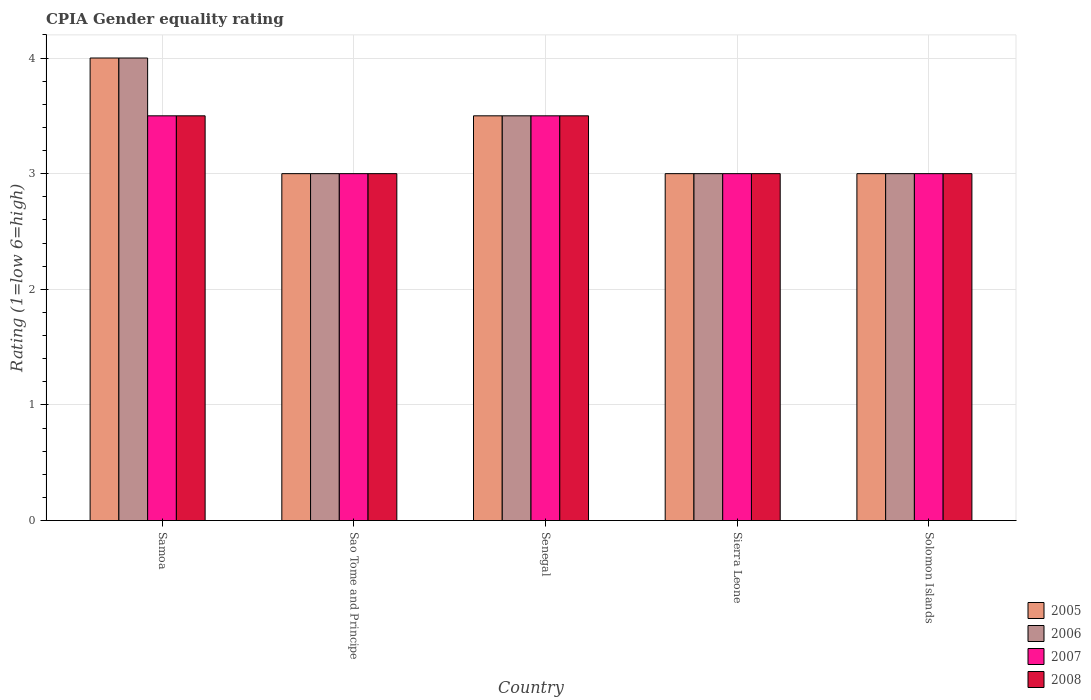How many different coloured bars are there?
Your answer should be very brief. 4. Are the number of bars on each tick of the X-axis equal?
Provide a short and direct response. Yes. What is the label of the 2nd group of bars from the left?
Your answer should be very brief. Sao Tome and Principe. In how many cases, is the number of bars for a given country not equal to the number of legend labels?
Provide a succinct answer. 0. What is the CPIA rating in 2007 in Senegal?
Keep it short and to the point. 3.5. In which country was the CPIA rating in 2007 maximum?
Ensure brevity in your answer.  Samoa. In which country was the CPIA rating in 2007 minimum?
Ensure brevity in your answer.  Sao Tome and Principe. What is the difference between the CPIA rating in 2006 in Senegal and that in Solomon Islands?
Ensure brevity in your answer.  0.5. What is the difference between the CPIA rating in 2005 in Sao Tome and Principe and the CPIA rating in 2006 in Sierra Leone?
Your answer should be compact. 0. In how many countries, is the CPIA rating in 2007 greater than 2.4?
Make the answer very short. 5. Is the difference between the CPIA rating in 2005 in Samoa and Sierra Leone greater than the difference between the CPIA rating in 2008 in Samoa and Sierra Leone?
Your answer should be very brief. Yes. What is the difference between the highest and the second highest CPIA rating in 2005?
Make the answer very short. -0.5. What is the difference between the highest and the lowest CPIA rating in 2006?
Keep it short and to the point. 1. In how many countries, is the CPIA rating in 2008 greater than the average CPIA rating in 2008 taken over all countries?
Provide a short and direct response. 2. Is the sum of the CPIA rating in 2007 in Sao Tome and Principe and Senegal greater than the maximum CPIA rating in 2006 across all countries?
Your answer should be compact. Yes. What does the 1st bar from the left in Samoa represents?
Make the answer very short. 2005. Is it the case that in every country, the sum of the CPIA rating in 2006 and CPIA rating in 2007 is greater than the CPIA rating in 2008?
Ensure brevity in your answer.  Yes. Are all the bars in the graph horizontal?
Your answer should be very brief. No. What is the difference between two consecutive major ticks on the Y-axis?
Your response must be concise. 1. Are the values on the major ticks of Y-axis written in scientific E-notation?
Your answer should be compact. No. Does the graph contain any zero values?
Give a very brief answer. No. Does the graph contain grids?
Provide a short and direct response. Yes. How many legend labels are there?
Give a very brief answer. 4. What is the title of the graph?
Provide a succinct answer. CPIA Gender equality rating. What is the Rating (1=low 6=high) of 2005 in Samoa?
Make the answer very short. 4. What is the Rating (1=low 6=high) of 2007 in Samoa?
Make the answer very short. 3.5. What is the Rating (1=low 6=high) of 2008 in Samoa?
Your response must be concise. 3.5. What is the Rating (1=low 6=high) in 2006 in Sao Tome and Principe?
Offer a terse response. 3. What is the Rating (1=low 6=high) in 2007 in Sao Tome and Principe?
Make the answer very short. 3. What is the Rating (1=low 6=high) of 2005 in Senegal?
Your response must be concise. 3.5. What is the Rating (1=low 6=high) of 2005 in Sierra Leone?
Your answer should be very brief. 3. What is the Rating (1=low 6=high) of 2006 in Sierra Leone?
Provide a short and direct response. 3. What is the Rating (1=low 6=high) in 2006 in Solomon Islands?
Provide a succinct answer. 3. What is the Rating (1=low 6=high) of 2007 in Solomon Islands?
Make the answer very short. 3. What is the Rating (1=low 6=high) of 2008 in Solomon Islands?
Keep it short and to the point. 3. Across all countries, what is the minimum Rating (1=low 6=high) in 2008?
Your answer should be compact. 3. What is the total Rating (1=low 6=high) of 2005 in the graph?
Keep it short and to the point. 16.5. What is the total Rating (1=low 6=high) of 2007 in the graph?
Keep it short and to the point. 16. What is the total Rating (1=low 6=high) in 2008 in the graph?
Provide a succinct answer. 16. What is the difference between the Rating (1=low 6=high) in 2005 in Samoa and that in Sao Tome and Principe?
Provide a succinct answer. 1. What is the difference between the Rating (1=low 6=high) in 2006 in Samoa and that in Sao Tome and Principe?
Your answer should be compact. 1. What is the difference between the Rating (1=low 6=high) in 2007 in Samoa and that in Sao Tome and Principe?
Give a very brief answer. 0.5. What is the difference between the Rating (1=low 6=high) of 2005 in Samoa and that in Senegal?
Your response must be concise. 0.5. What is the difference between the Rating (1=low 6=high) in 2006 in Samoa and that in Senegal?
Offer a terse response. 0.5. What is the difference between the Rating (1=low 6=high) of 2008 in Samoa and that in Senegal?
Make the answer very short. 0. What is the difference between the Rating (1=low 6=high) of 2006 in Samoa and that in Sierra Leone?
Offer a terse response. 1. What is the difference between the Rating (1=low 6=high) of 2005 in Samoa and that in Solomon Islands?
Give a very brief answer. 1. What is the difference between the Rating (1=low 6=high) in 2007 in Samoa and that in Solomon Islands?
Ensure brevity in your answer.  0.5. What is the difference between the Rating (1=low 6=high) of 2008 in Samoa and that in Solomon Islands?
Give a very brief answer. 0.5. What is the difference between the Rating (1=low 6=high) of 2005 in Sao Tome and Principe and that in Senegal?
Your response must be concise. -0.5. What is the difference between the Rating (1=low 6=high) in 2006 in Sao Tome and Principe and that in Senegal?
Ensure brevity in your answer.  -0.5. What is the difference between the Rating (1=low 6=high) of 2006 in Sao Tome and Principe and that in Sierra Leone?
Keep it short and to the point. 0. What is the difference between the Rating (1=low 6=high) of 2007 in Sao Tome and Principe and that in Sierra Leone?
Your response must be concise. 0. What is the difference between the Rating (1=low 6=high) in 2008 in Sao Tome and Principe and that in Sierra Leone?
Give a very brief answer. 0. What is the difference between the Rating (1=low 6=high) of 2008 in Sao Tome and Principe and that in Solomon Islands?
Give a very brief answer. 0. What is the difference between the Rating (1=low 6=high) in 2006 in Senegal and that in Sierra Leone?
Offer a terse response. 0.5. What is the difference between the Rating (1=low 6=high) in 2008 in Senegal and that in Sierra Leone?
Offer a very short reply. 0.5. What is the difference between the Rating (1=low 6=high) of 2005 in Senegal and that in Solomon Islands?
Ensure brevity in your answer.  0.5. What is the difference between the Rating (1=low 6=high) in 2008 in Senegal and that in Solomon Islands?
Offer a terse response. 0.5. What is the difference between the Rating (1=low 6=high) of 2008 in Sierra Leone and that in Solomon Islands?
Ensure brevity in your answer.  0. What is the difference between the Rating (1=low 6=high) in 2005 in Samoa and the Rating (1=low 6=high) in 2006 in Sao Tome and Principe?
Keep it short and to the point. 1. What is the difference between the Rating (1=low 6=high) of 2005 in Samoa and the Rating (1=low 6=high) of 2007 in Sao Tome and Principe?
Keep it short and to the point. 1. What is the difference between the Rating (1=low 6=high) in 2005 in Samoa and the Rating (1=low 6=high) in 2008 in Sao Tome and Principe?
Ensure brevity in your answer.  1. What is the difference between the Rating (1=low 6=high) of 2006 in Samoa and the Rating (1=low 6=high) of 2007 in Sao Tome and Principe?
Offer a terse response. 1. What is the difference between the Rating (1=low 6=high) of 2006 in Samoa and the Rating (1=low 6=high) of 2008 in Sao Tome and Principe?
Give a very brief answer. 1. What is the difference between the Rating (1=low 6=high) of 2007 in Samoa and the Rating (1=low 6=high) of 2008 in Sao Tome and Principe?
Provide a succinct answer. 0.5. What is the difference between the Rating (1=low 6=high) of 2005 in Samoa and the Rating (1=low 6=high) of 2006 in Senegal?
Provide a succinct answer. 0.5. What is the difference between the Rating (1=low 6=high) in 2006 in Samoa and the Rating (1=low 6=high) in 2008 in Senegal?
Make the answer very short. 0.5. What is the difference between the Rating (1=low 6=high) in 2005 in Samoa and the Rating (1=low 6=high) in 2006 in Solomon Islands?
Keep it short and to the point. 1. What is the difference between the Rating (1=low 6=high) in 2006 in Samoa and the Rating (1=low 6=high) in 2007 in Solomon Islands?
Ensure brevity in your answer.  1. What is the difference between the Rating (1=low 6=high) of 2007 in Samoa and the Rating (1=low 6=high) of 2008 in Solomon Islands?
Ensure brevity in your answer.  0.5. What is the difference between the Rating (1=low 6=high) of 2005 in Sao Tome and Principe and the Rating (1=low 6=high) of 2007 in Senegal?
Give a very brief answer. -0.5. What is the difference between the Rating (1=low 6=high) in 2006 in Sao Tome and Principe and the Rating (1=low 6=high) in 2008 in Senegal?
Offer a very short reply. -0.5. What is the difference between the Rating (1=low 6=high) of 2005 in Sao Tome and Principe and the Rating (1=low 6=high) of 2007 in Sierra Leone?
Make the answer very short. 0. What is the difference between the Rating (1=low 6=high) in 2006 in Sao Tome and Principe and the Rating (1=low 6=high) in 2007 in Sierra Leone?
Provide a short and direct response. 0. What is the difference between the Rating (1=low 6=high) of 2006 in Sao Tome and Principe and the Rating (1=low 6=high) of 2008 in Sierra Leone?
Offer a terse response. 0. What is the difference between the Rating (1=low 6=high) of 2005 in Sao Tome and Principe and the Rating (1=low 6=high) of 2006 in Solomon Islands?
Offer a very short reply. 0. What is the difference between the Rating (1=low 6=high) in 2005 in Sao Tome and Principe and the Rating (1=low 6=high) in 2007 in Solomon Islands?
Your response must be concise. 0. What is the difference between the Rating (1=low 6=high) in 2005 in Sao Tome and Principe and the Rating (1=low 6=high) in 2008 in Solomon Islands?
Ensure brevity in your answer.  0. What is the difference between the Rating (1=low 6=high) in 2007 in Sao Tome and Principe and the Rating (1=low 6=high) in 2008 in Solomon Islands?
Your answer should be very brief. 0. What is the difference between the Rating (1=low 6=high) in 2005 in Senegal and the Rating (1=low 6=high) in 2007 in Sierra Leone?
Offer a terse response. 0.5. What is the difference between the Rating (1=low 6=high) of 2005 in Senegal and the Rating (1=low 6=high) of 2008 in Sierra Leone?
Offer a terse response. 0.5. What is the difference between the Rating (1=low 6=high) in 2007 in Senegal and the Rating (1=low 6=high) in 2008 in Sierra Leone?
Offer a terse response. 0.5. What is the difference between the Rating (1=low 6=high) in 2005 in Senegal and the Rating (1=low 6=high) in 2006 in Solomon Islands?
Offer a very short reply. 0.5. What is the difference between the Rating (1=low 6=high) of 2005 in Senegal and the Rating (1=low 6=high) of 2008 in Solomon Islands?
Offer a very short reply. 0.5. What is the difference between the Rating (1=low 6=high) in 2006 in Senegal and the Rating (1=low 6=high) in 2007 in Solomon Islands?
Provide a short and direct response. 0.5. What is the difference between the Rating (1=low 6=high) of 2005 in Sierra Leone and the Rating (1=low 6=high) of 2006 in Solomon Islands?
Give a very brief answer. 0. What is the difference between the Rating (1=low 6=high) in 2005 in Sierra Leone and the Rating (1=low 6=high) in 2007 in Solomon Islands?
Offer a terse response. 0. What is the difference between the Rating (1=low 6=high) of 2005 in Sierra Leone and the Rating (1=low 6=high) of 2008 in Solomon Islands?
Your response must be concise. 0. What is the difference between the Rating (1=low 6=high) of 2007 in Sierra Leone and the Rating (1=low 6=high) of 2008 in Solomon Islands?
Provide a succinct answer. 0. What is the average Rating (1=low 6=high) in 2007 per country?
Make the answer very short. 3.2. What is the difference between the Rating (1=low 6=high) in 2005 and Rating (1=low 6=high) in 2006 in Samoa?
Give a very brief answer. 0. What is the difference between the Rating (1=low 6=high) in 2005 and Rating (1=low 6=high) in 2007 in Samoa?
Your response must be concise. 0.5. What is the difference between the Rating (1=low 6=high) of 2005 and Rating (1=low 6=high) of 2008 in Samoa?
Provide a short and direct response. 0.5. What is the difference between the Rating (1=low 6=high) in 2006 and Rating (1=low 6=high) in 2007 in Samoa?
Ensure brevity in your answer.  0.5. What is the difference between the Rating (1=low 6=high) in 2005 and Rating (1=low 6=high) in 2007 in Sao Tome and Principe?
Provide a succinct answer. 0. What is the difference between the Rating (1=low 6=high) in 2006 and Rating (1=low 6=high) in 2008 in Sao Tome and Principe?
Offer a terse response. 0. What is the difference between the Rating (1=low 6=high) in 2005 and Rating (1=low 6=high) in 2007 in Senegal?
Offer a very short reply. 0. What is the difference between the Rating (1=low 6=high) of 2006 and Rating (1=low 6=high) of 2007 in Senegal?
Give a very brief answer. 0. What is the difference between the Rating (1=low 6=high) in 2006 and Rating (1=low 6=high) in 2008 in Senegal?
Keep it short and to the point. 0. What is the difference between the Rating (1=low 6=high) in 2005 and Rating (1=low 6=high) in 2006 in Sierra Leone?
Your answer should be compact. 0. What is the difference between the Rating (1=low 6=high) in 2005 and Rating (1=low 6=high) in 2006 in Solomon Islands?
Provide a succinct answer. 0. What is the difference between the Rating (1=low 6=high) of 2005 and Rating (1=low 6=high) of 2008 in Solomon Islands?
Your answer should be compact. 0. What is the difference between the Rating (1=low 6=high) in 2006 and Rating (1=low 6=high) in 2007 in Solomon Islands?
Offer a terse response. 0. What is the difference between the Rating (1=low 6=high) in 2006 and Rating (1=low 6=high) in 2008 in Solomon Islands?
Provide a succinct answer. 0. What is the ratio of the Rating (1=low 6=high) of 2005 in Samoa to that in Sao Tome and Principe?
Ensure brevity in your answer.  1.33. What is the ratio of the Rating (1=low 6=high) of 2007 in Samoa to that in Sao Tome and Principe?
Your response must be concise. 1.17. What is the ratio of the Rating (1=low 6=high) in 2005 in Samoa to that in Senegal?
Provide a short and direct response. 1.14. What is the ratio of the Rating (1=low 6=high) of 2006 in Samoa to that in Senegal?
Make the answer very short. 1.14. What is the ratio of the Rating (1=low 6=high) of 2008 in Samoa to that in Senegal?
Give a very brief answer. 1. What is the ratio of the Rating (1=low 6=high) of 2005 in Samoa to that in Sierra Leone?
Ensure brevity in your answer.  1.33. What is the ratio of the Rating (1=low 6=high) of 2008 in Samoa to that in Sierra Leone?
Give a very brief answer. 1.17. What is the ratio of the Rating (1=low 6=high) in 2006 in Samoa to that in Solomon Islands?
Give a very brief answer. 1.33. What is the ratio of the Rating (1=low 6=high) in 2008 in Samoa to that in Solomon Islands?
Make the answer very short. 1.17. What is the ratio of the Rating (1=low 6=high) in 2005 in Sao Tome and Principe to that in Senegal?
Your response must be concise. 0.86. What is the ratio of the Rating (1=low 6=high) of 2006 in Sao Tome and Principe to that in Senegal?
Offer a terse response. 0.86. What is the ratio of the Rating (1=low 6=high) of 2008 in Sao Tome and Principe to that in Senegal?
Your answer should be very brief. 0.86. What is the ratio of the Rating (1=low 6=high) in 2007 in Sao Tome and Principe to that in Sierra Leone?
Provide a short and direct response. 1. What is the ratio of the Rating (1=low 6=high) of 2008 in Sao Tome and Principe to that in Sierra Leone?
Provide a succinct answer. 1. What is the ratio of the Rating (1=low 6=high) of 2006 in Sao Tome and Principe to that in Solomon Islands?
Keep it short and to the point. 1. What is the ratio of the Rating (1=low 6=high) in 2008 in Sao Tome and Principe to that in Solomon Islands?
Offer a terse response. 1. What is the ratio of the Rating (1=low 6=high) of 2006 in Senegal to that in Sierra Leone?
Your answer should be very brief. 1.17. What is the ratio of the Rating (1=low 6=high) of 2007 in Senegal to that in Sierra Leone?
Give a very brief answer. 1.17. What is the ratio of the Rating (1=low 6=high) in 2006 in Senegal to that in Solomon Islands?
Provide a short and direct response. 1.17. What is the ratio of the Rating (1=low 6=high) of 2008 in Senegal to that in Solomon Islands?
Give a very brief answer. 1.17. What is the ratio of the Rating (1=low 6=high) of 2005 in Sierra Leone to that in Solomon Islands?
Make the answer very short. 1. What is the ratio of the Rating (1=low 6=high) of 2007 in Sierra Leone to that in Solomon Islands?
Offer a very short reply. 1. What is the difference between the highest and the second highest Rating (1=low 6=high) of 2006?
Keep it short and to the point. 0.5. What is the difference between the highest and the second highest Rating (1=low 6=high) of 2008?
Give a very brief answer. 0. What is the difference between the highest and the lowest Rating (1=low 6=high) in 2005?
Ensure brevity in your answer.  1. What is the difference between the highest and the lowest Rating (1=low 6=high) of 2006?
Make the answer very short. 1. 